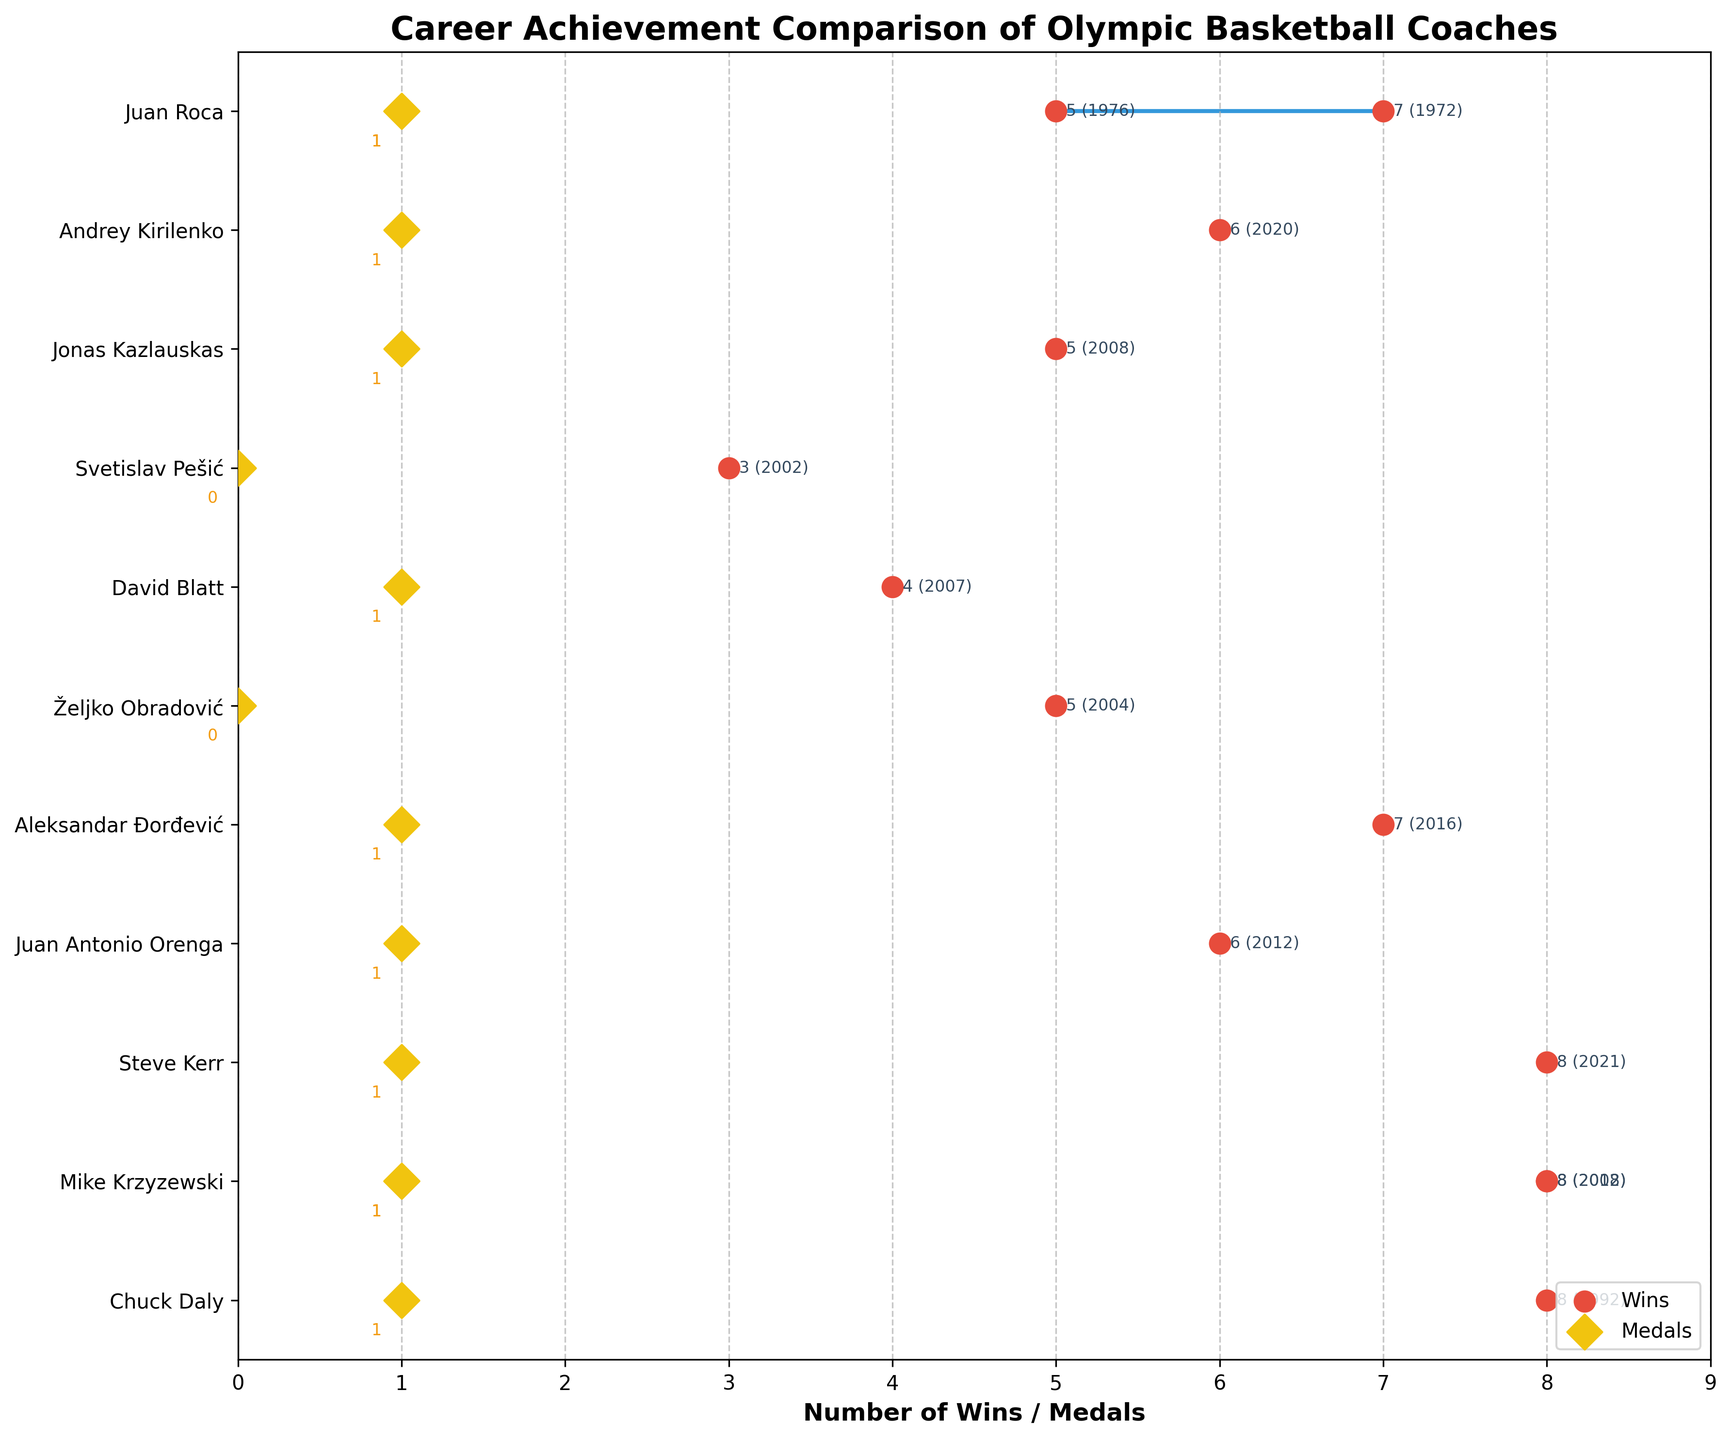What's the title of the figure? The title of the figure is usually located at the top and summarizes what the plot is about. In this case, it says "Career Achievement Comparison of Olympic Basketball Coaches."
Answer: Career Achievement Comparison of Olympic Basketball Coaches What does the horizontal axis represent? The labeling on the horizontal axis indicates the metric being measured. Here, it is labeled "Number of Wins / Medals," which means it represents the number of wins or medals each coach has achieved.
Answer: Number of Wins / Medals Which coach has the highest number of wins in a single year? By observing the highest point on the horizontal axis where the red circular markers (representing wins) are located, we see the name next to that point is Chuck Daly (1992), Mike Krzyzewski (2008, 2012), and Steve Kerr (2021) all with 8 wins.
Answer: Chuck Daly (1992), Mike Krzyzewski (2008, 2012), and Steve Kerr (2021) How many coaches have won exactly 7 games in the Olympics? Observing the red markers and their corresponding labels along the axis and y-coordinates, it is clear that Juan Roca (1972) and Aleksandar Đorđević (2016) both have 7 wins.
Answer: 2 Which coach has the largest difference between their maximum wins and medals? To find this, calculate the difference between the maximum number of wins and medals for each coach. The coach with the largest difference is Željko Obradović in 2004, with 5 wins and 0 medals, a difference of 5.
Answer: Željko Obradović (2004) Which coach’s performance is represented at y=3? By matching the y-tick labels to the y-positions, the corresponding coach at y=3 is Steve Kerr.
Answer: Steve Kerr How many times has Juan Roca appeared as a coach in the Olympics according to the plot? Juan Roca appears twice, once for each of the years 1972 and 1976.
Answer: 2 Compare the number of medals won by David Blatt and Jonas Kazlauskas. Who has more and by how many? Both David Blatt and Jonas Kazlauskas are represented by yellow diamond markers. They both have one medal each, so the difference is zero.
Answer: Equal (0) What's the difference in the number of wins between Svetislav Pešić and Andrey Kirilenko? Svetislav Pešić has 3 wins and Andrey Kirilenko has 6 wins. The difference between their wins is 6 - 3 = 3.
Answer: 3 Which coach has a significant number of wins in the early '70s? By matching the years and names, Juan Roca is the coach with significant wins (7 in 1972 and 5 in 1976) during the early '70s.
Answer: Juan Roca 